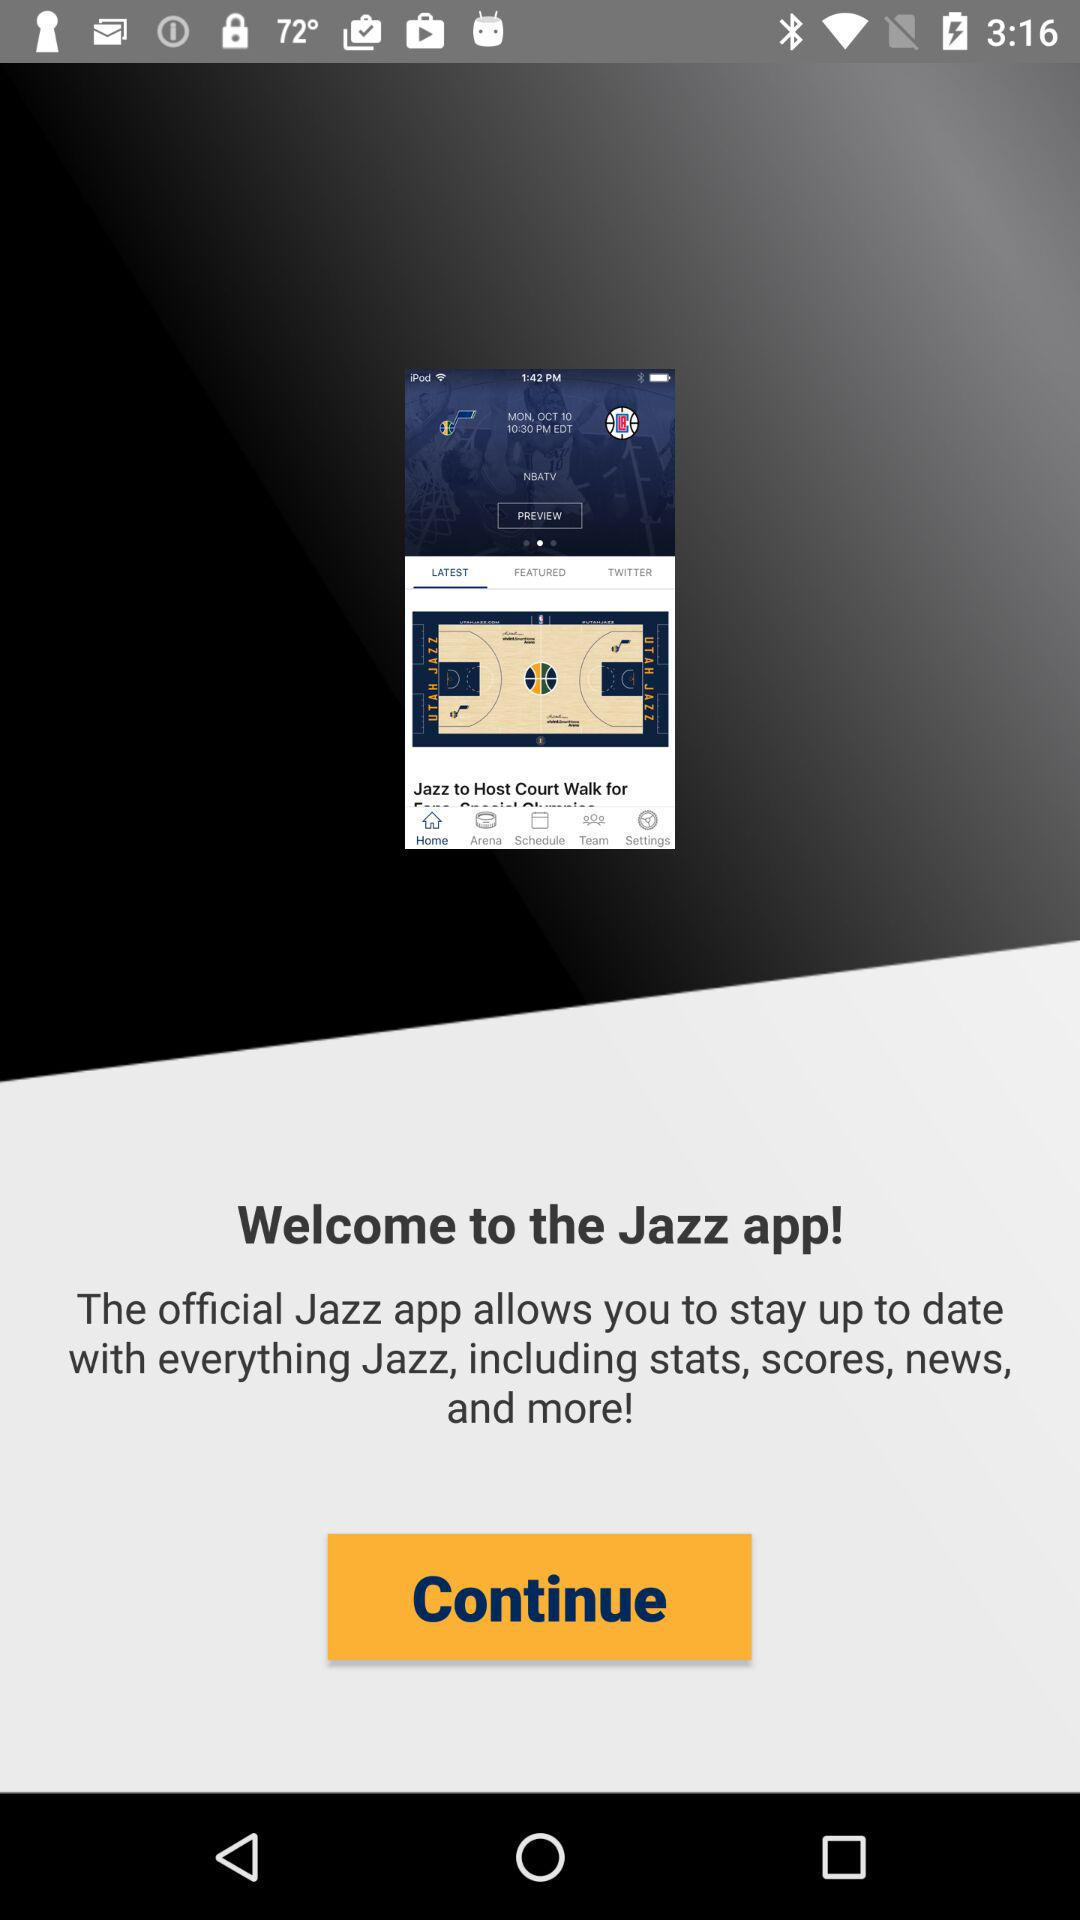To which city does the "Jazz" belong?
When the provided information is insufficient, respond with <no answer>. <no answer> 